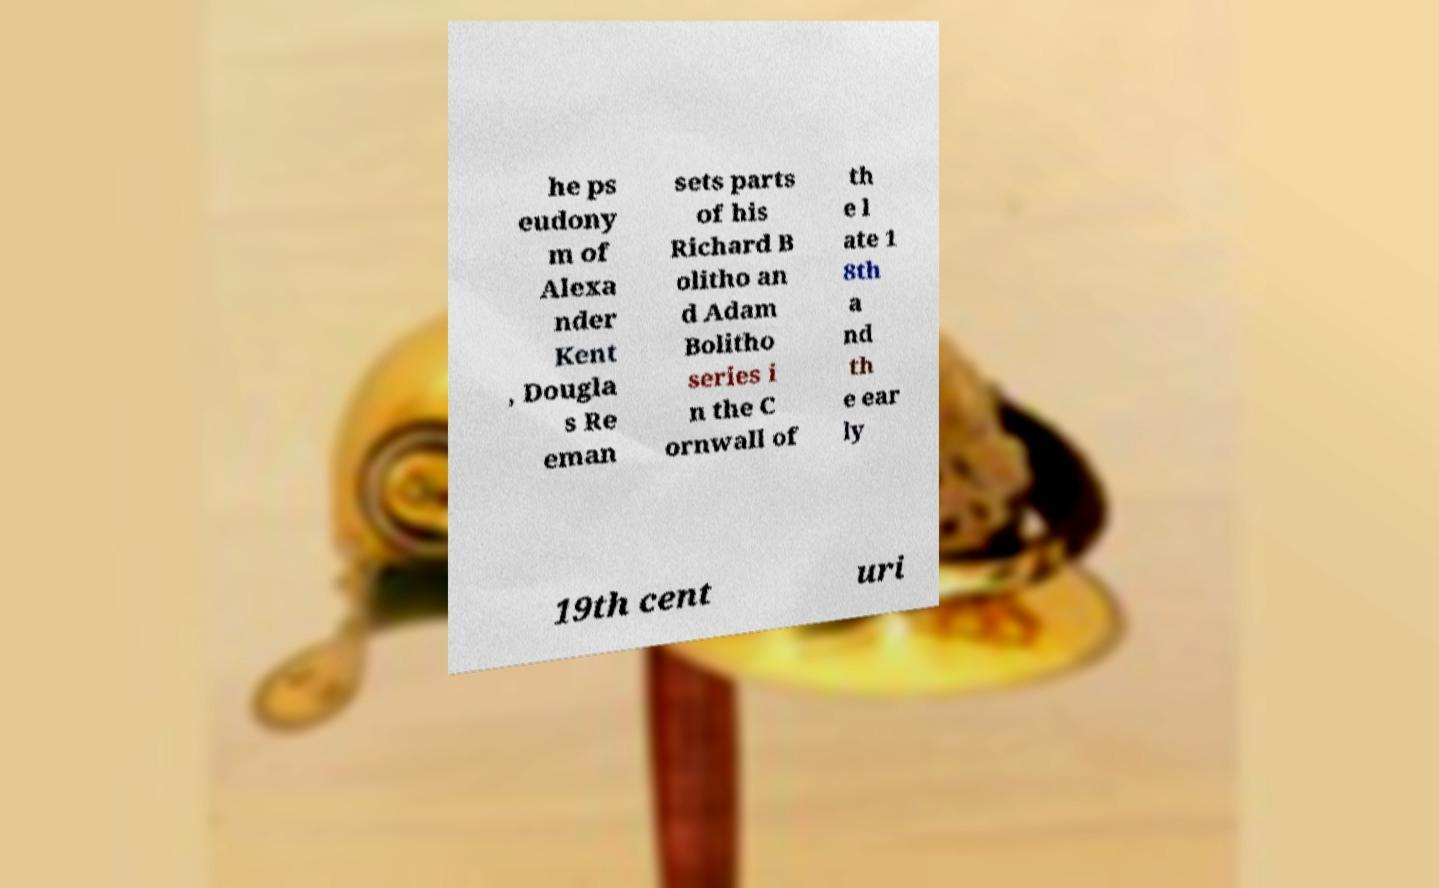Can you accurately transcribe the text from the provided image for me? he ps eudony m of Alexa nder Kent , Dougla s Re eman sets parts of his Richard B olitho an d Adam Bolitho series i n the C ornwall of th e l ate 1 8th a nd th e ear ly 19th cent uri 